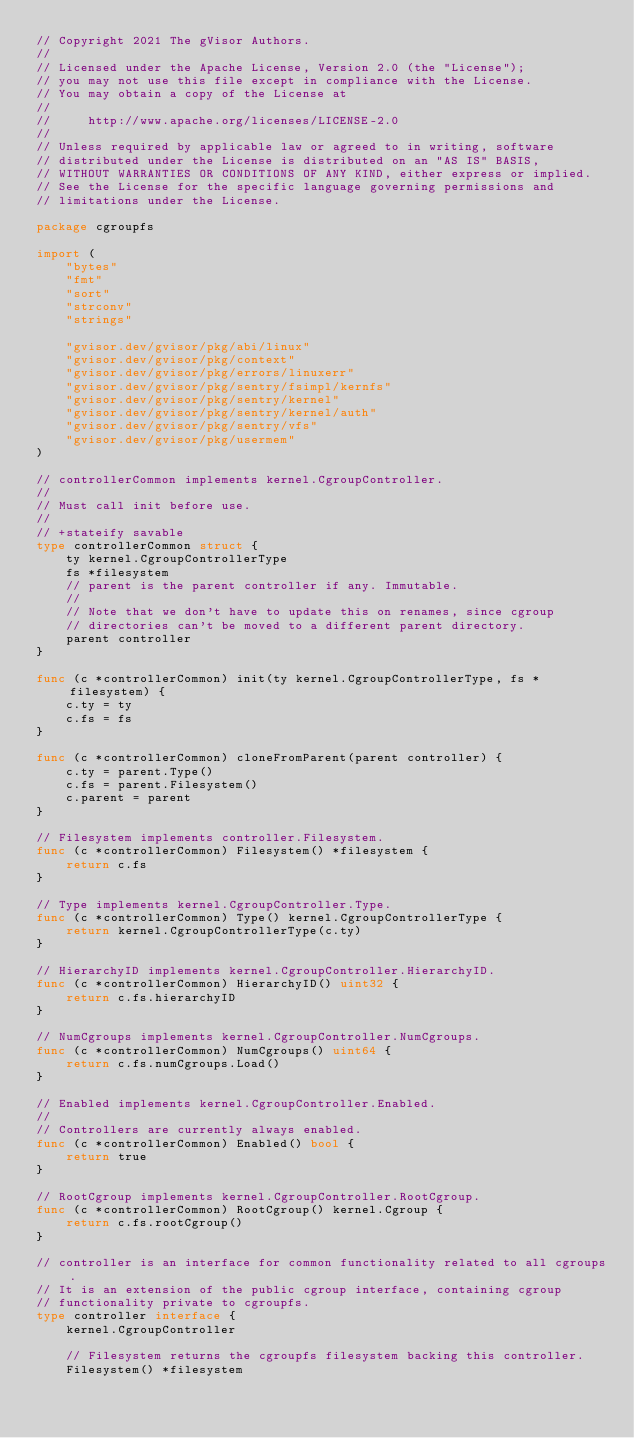<code> <loc_0><loc_0><loc_500><loc_500><_Go_>// Copyright 2021 The gVisor Authors.
//
// Licensed under the Apache License, Version 2.0 (the "License");
// you may not use this file except in compliance with the License.
// You may obtain a copy of the License at
//
//     http://www.apache.org/licenses/LICENSE-2.0
//
// Unless required by applicable law or agreed to in writing, software
// distributed under the License is distributed on an "AS IS" BASIS,
// WITHOUT WARRANTIES OR CONDITIONS OF ANY KIND, either express or implied.
// See the License for the specific language governing permissions and
// limitations under the License.

package cgroupfs

import (
	"bytes"
	"fmt"
	"sort"
	"strconv"
	"strings"

	"gvisor.dev/gvisor/pkg/abi/linux"
	"gvisor.dev/gvisor/pkg/context"
	"gvisor.dev/gvisor/pkg/errors/linuxerr"
	"gvisor.dev/gvisor/pkg/sentry/fsimpl/kernfs"
	"gvisor.dev/gvisor/pkg/sentry/kernel"
	"gvisor.dev/gvisor/pkg/sentry/kernel/auth"
	"gvisor.dev/gvisor/pkg/sentry/vfs"
	"gvisor.dev/gvisor/pkg/usermem"
)

// controllerCommon implements kernel.CgroupController.
//
// Must call init before use.
//
// +stateify savable
type controllerCommon struct {
	ty kernel.CgroupControllerType
	fs *filesystem
	// parent is the parent controller if any. Immutable.
	//
	// Note that we don't have to update this on renames, since cgroup
	// directories can't be moved to a different parent directory.
	parent controller
}

func (c *controllerCommon) init(ty kernel.CgroupControllerType, fs *filesystem) {
	c.ty = ty
	c.fs = fs
}

func (c *controllerCommon) cloneFromParent(parent controller) {
	c.ty = parent.Type()
	c.fs = parent.Filesystem()
	c.parent = parent
}

// Filesystem implements controller.Filesystem.
func (c *controllerCommon) Filesystem() *filesystem {
	return c.fs
}

// Type implements kernel.CgroupController.Type.
func (c *controllerCommon) Type() kernel.CgroupControllerType {
	return kernel.CgroupControllerType(c.ty)
}

// HierarchyID implements kernel.CgroupController.HierarchyID.
func (c *controllerCommon) HierarchyID() uint32 {
	return c.fs.hierarchyID
}

// NumCgroups implements kernel.CgroupController.NumCgroups.
func (c *controllerCommon) NumCgroups() uint64 {
	return c.fs.numCgroups.Load()
}

// Enabled implements kernel.CgroupController.Enabled.
//
// Controllers are currently always enabled.
func (c *controllerCommon) Enabled() bool {
	return true
}

// RootCgroup implements kernel.CgroupController.RootCgroup.
func (c *controllerCommon) RootCgroup() kernel.Cgroup {
	return c.fs.rootCgroup()
}

// controller is an interface for common functionality related to all cgroups.
// It is an extension of the public cgroup interface, containing cgroup
// functionality private to cgroupfs.
type controller interface {
	kernel.CgroupController

	// Filesystem returns the cgroupfs filesystem backing this controller.
	Filesystem() *filesystem
</code> 